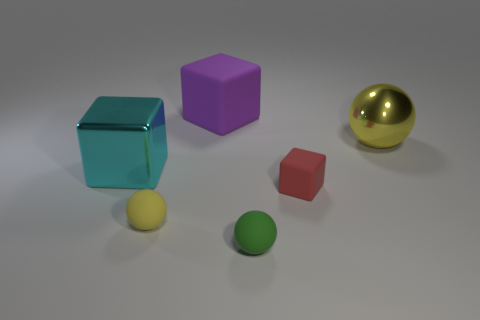What materials do the objects in the image seem to be made of? The objects in the image appear to have different materials. The blue cube looks like it could be made of a glass-like or transparent material, the purple cube seems to be matte, perhaps a type of plastic, and the golden ball has a reflective surface that suggests it could be made of metal. 